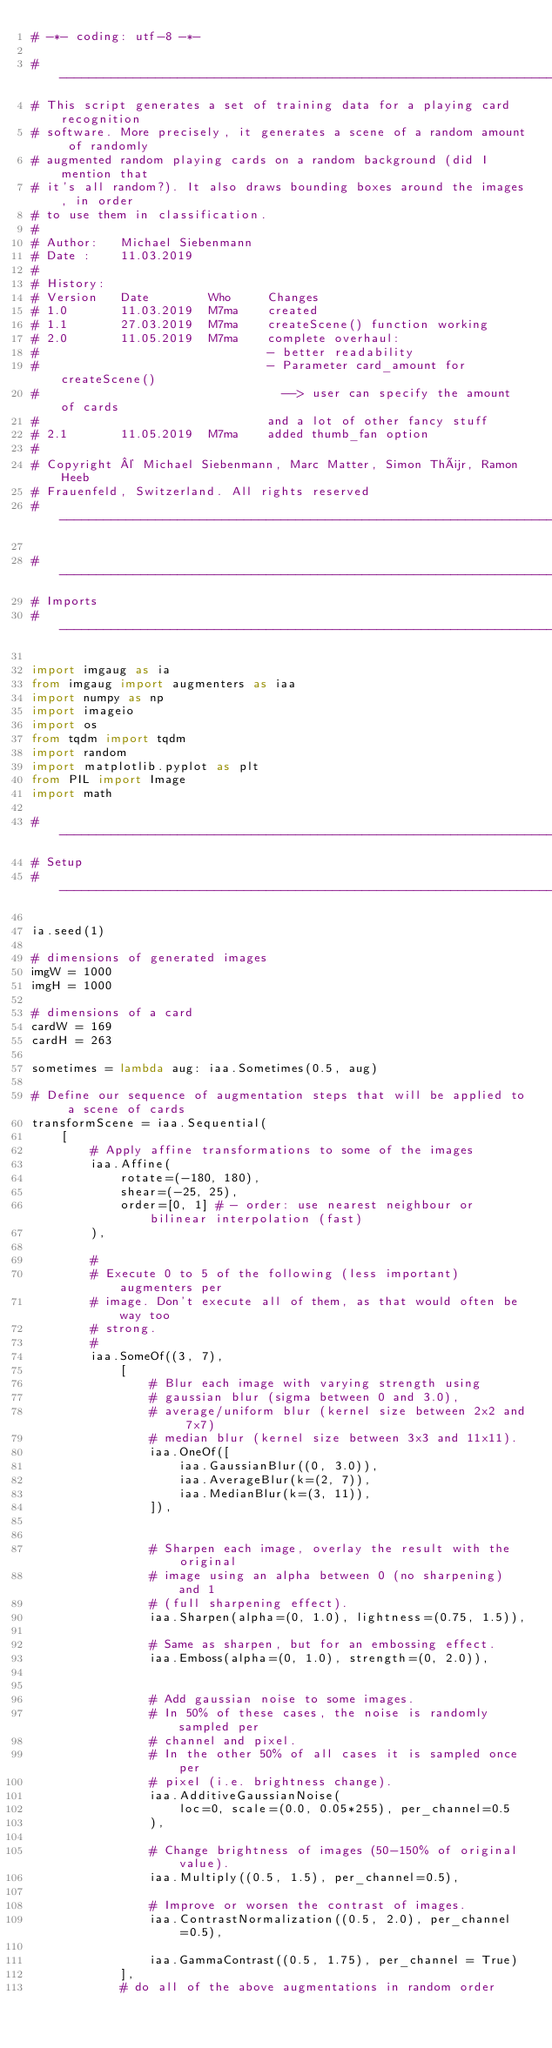Convert code to text. <code><loc_0><loc_0><loc_500><loc_500><_Python_># -*- coding: utf-8 -*-

# -----------------------------------------------------------------------------
# This script generates a set of training data for a playing card recognition
# software. More precisely, it generates a scene of a random amount of randomly 
# augmented random playing cards on a random background (did I mention that 
# it's all random?). It also draws bounding boxes around the images, in order
# to use them in classification.
#
# Author:   Michael Siebenmann
# Date :    11.03.2019
#
# History:
# Version   Date        Who     Changes
# 1.0       11.03.2019  M7ma    created
# 1.1       27.03.2019	M7ma	createScene() function working
# 2.0       11.05.2019  M7ma    complete overhaul:
#                               - better readability
#                               - Parameter card_amount for createScene()
#                                 --> user can specify the amount of cards
#                               and a lot of other fancy stuff
# 2.1       11.05.2019  M7ma    added thumb_fan option
#
# Copyright © Michael Siebenmann, Marc Matter, Simon Thür, Ramon Heeb
# Frauenfeld, Switzerland. All rights reserved
# -----------------------------------------------------------------------------

# -----------------------------------------------------------------------------
# Imports
# -----------------------------------------------------------------------------

import imgaug as ia
from imgaug import augmenters as iaa
import numpy as np
import imageio
import os
from tqdm import tqdm
import random
import matplotlib.pyplot as plt
from PIL import Image
import math

# -----------------------------------------------------------------------------
# Setup
# -----------------------------------------------------------------------------

ia.seed(1)

# dimensions of generated images
imgW = 1000
imgH = 1000

# dimensions of a card
cardW = 169
cardH = 263

sometimes = lambda aug: iaa.Sometimes(0.5, aug)

# Define our sequence of augmentation steps that will be applied to a scene of cards
transformScene = iaa.Sequential(
    [
        # Apply affine transformations to some of the images      
        iaa.Affine(
            rotate=(-180, 180),
            shear=(-25, 25),
            order=[0, 1] # - order: use nearest neighbour or bilinear interpolation (fast)
        ),

        #
        # Execute 0 to 5 of the following (less important) augmenters per
        # image. Don't execute all of them, as that would often be way too
        # strong.
        #
        iaa.SomeOf((3, 7),
            [
                # Blur each image with varying strength using
                # gaussian blur (sigma between 0 and 3.0),
                # average/uniform blur (kernel size between 2x2 and 7x7)
                # median blur (kernel size between 3x3 and 11x11).
                iaa.OneOf([
                    iaa.GaussianBlur((0, 3.0)),
                    iaa.AverageBlur(k=(2, 7)),
                    iaa.MedianBlur(k=(3, 11)),
                ]),
                
                
                # Sharpen each image, overlay the result with the original
                # image using an alpha between 0 (no sharpening) and 1
                # (full sharpening effect).
                iaa.Sharpen(alpha=(0, 1.0), lightness=(0.75, 1.5)),

                # Same as sharpen, but for an embossing effect.
                iaa.Emboss(alpha=(0, 1.0), strength=(0, 2.0)),

                
                # Add gaussian noise to some images.
                # In 50% of these cases, the noise is randomly sampled per
                # channel and pixel.
                # In the other 50% of all cases it is sampled once per
                # pixel (i.e. brightness change).
                iaa.AdditiveGaussianNoise(
                    loc=0, scale=(0.0, 0.05*255), per_channel=0.5
                ),

                # Change brightness of images (50-150% of original value).
                iaa.Multiply((0.5, 1.5), per_channel=0.5),

                # Improve or worsen the contrast of images.
                iaa.ContrastNormalization((0.5, 2.0), per_channel=0.5),
                
                iaa.GammaContrast((0.5, 1.75), per_channel = True)
            ],
            # do all of the above augmentations in random order</code> 